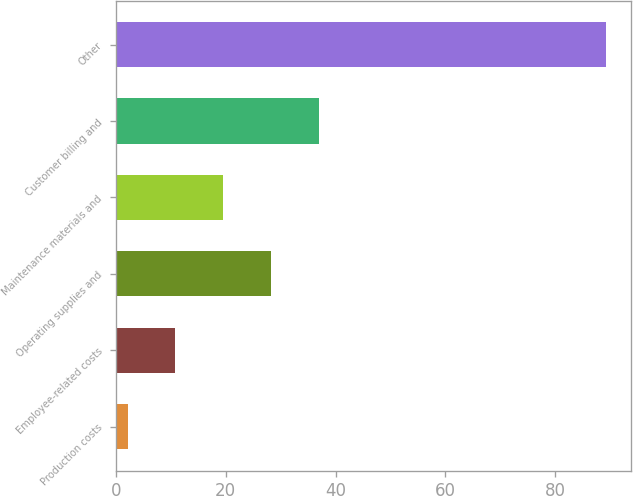Convert chart to OTSL. <chart><loc_0><loc_0><loc_500><loc_500><bar_chart><fcel>Production costs<fcel>Employee-related costs<fcel>Operating supplies and<fcel>Maintenance materials and<fcel>Customer billing and<fcel>Other<nl><fcel>2.1<fcel>10.82<fcel>28.26<fcel>19.54<fcel>36.98<fcel>89.3<nl></chart> 